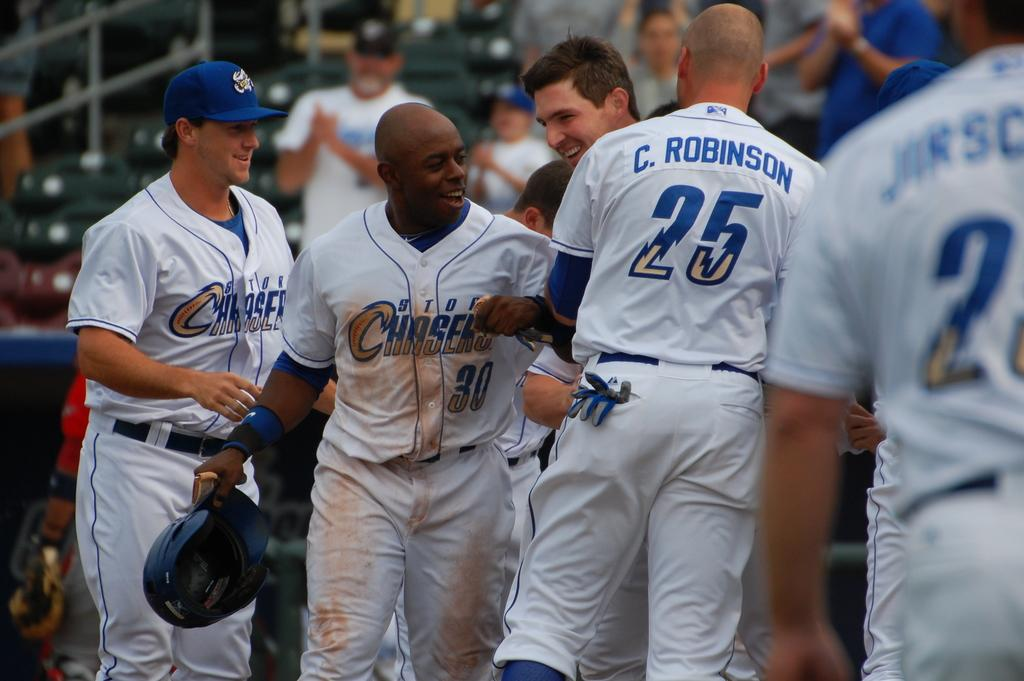<image>
Present a compact description of the photo's key features. Storm Chasers players celebrate together during a baseball game. 